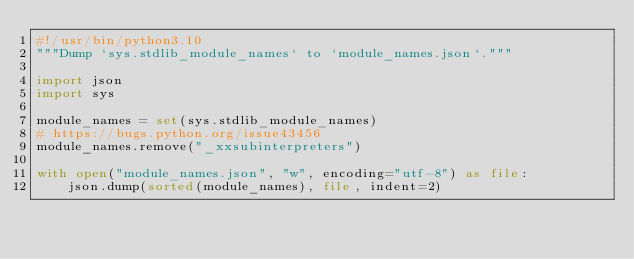<code> <loc_0><loc_0><loc_500><loc_500><_Python_>#!/usr/bin/python3.10
"""Dump `sys.stdlib_module_names` to `module_names.json`."""

import json
import sys

module_names = set(sys.stdlib_module_names)
# https://bugs.python.org/issue43456
module_names.remove("_xxsubinterpreters")

with open("module_names.json", "w", encoding="utf-8") as file:
    json.dump(sorted(module_names), file, indent=2)
</code> 